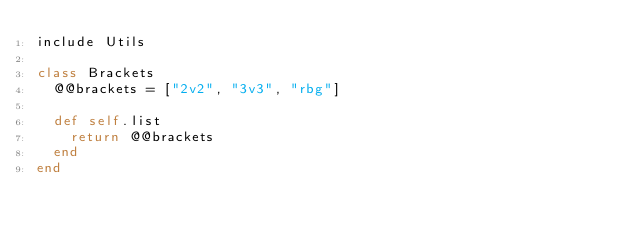<code> <loc_0><loc_0><loc_500><loc_500><_Ruby_>include Utils

class Brackets
	@@brackets = ["2v2", "3v3", "rbg"]

	def self.list
	  return @@brackets
	end
end</code> 